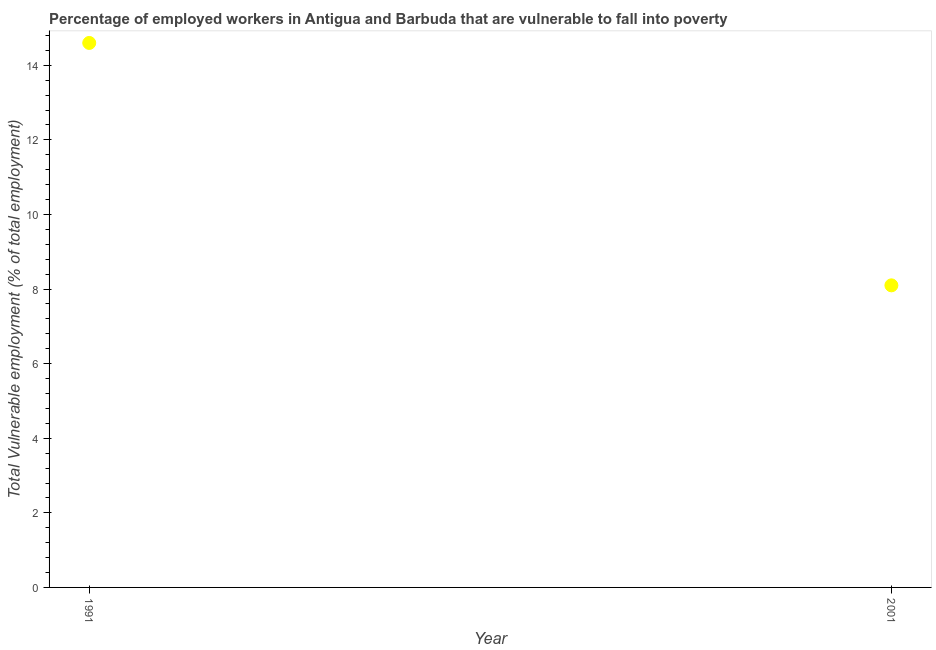What is the total vulnerable employment in 1991?
Provide a succinct answer. 14.6. Across all years, what is the maximum total vulnerable employment?
Offer a very short reply. 14.6. Across all years, what is the minimum total vulnerable employment?
Your response must be concise. 8.1. In which year was the total vulnerable employment maximum?
Ensure brevity in your answer.  1991. What is the sum of the total vulnerable employment?
Your answer should be very brief. 22.7. What is the difference between the total vulnerable employment in 1991 and 2001?
Your answer should be compact. 6.5. What is the average total vulnerable employment per year?
Your response must be concise. 11.35. What is the median total vulnerable employment?
Provide a succinct answer. 11.35. In how many years, is the total vulnerable employment greater than 2.8 %?
Offer a terse response. 2. What is the ratio of the total vulnerable employment in 1991 to that in 2001?
Make the answer very short. 1.8. Is the total vulnerable employment in 1991 less than that in 2001?
Offer a very short reply. No. Does the total vulnerable employment monotonically increase over the years?
Offer a terse response. No. How many years are there in the graph?
Provide a succinct answer. 2. What is the difference between two consecutive major ticks on the Y-axis?
Provide a short and direct response. 2. Does the graph contain any zero values?
Offer a terse response. No. What is the title of the graph?
Your answer should be compact. Percentage of employed workers in Antigua and Barbuda that are vulnerable to fall into poverty. What is the label or title of the X-axis?
Offer a terse response. Year. What is the label or title of the Y-axis?
Give a very brief answer. Total Vulnerable employment (% of total employment). What is the Total Vulnerable employment (% of total employment) in 1991?
Offer a very short reply. 14.6. What is the Total Vulnerable employment (% of total employment) in 2001?
Offer a terse response. 8.1. What is the ratio of the Total Vulnerable employment (% of total employment) in 1991 to that in 2001?
Offer a terse response. 1.8. 